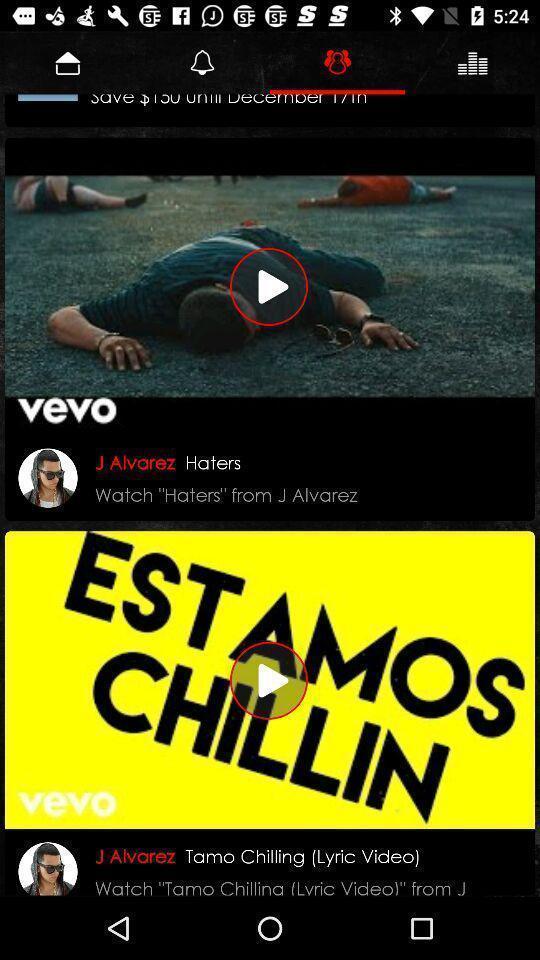What is the overall content of this screenshot? Screen shows videos. 